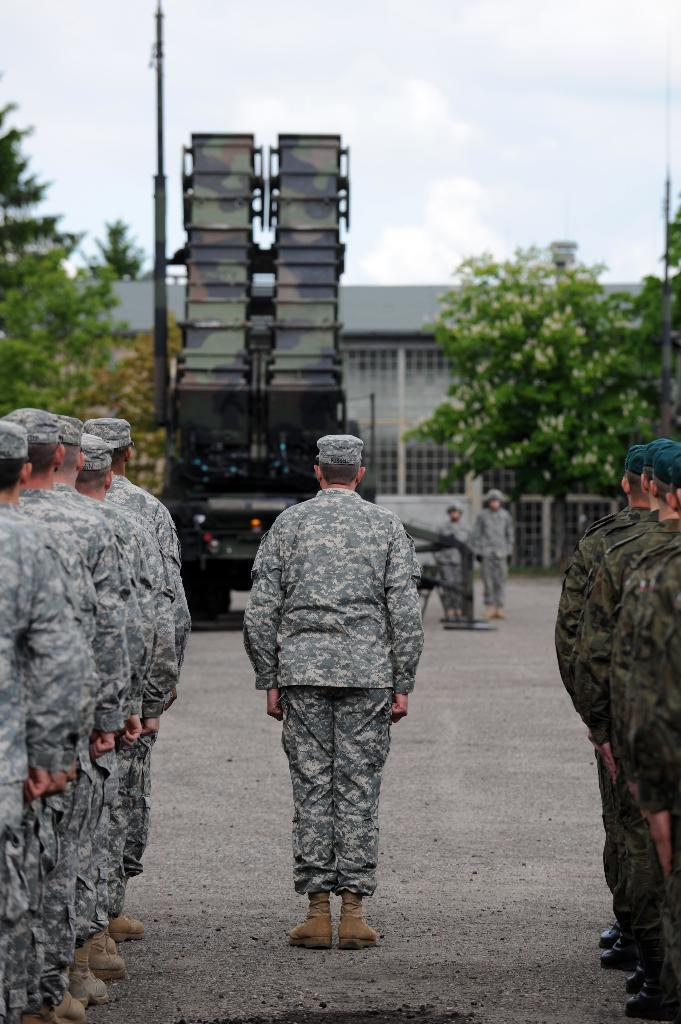What are the people in the image doing? The persons in the image are standing on the road. What type of vehicle can be seen in the image? There is a motor vehicle in the image. What natural elements are present in the image? There are trees in the image. What type of structure is visible in the image? There is a building in the image. What artificial light source is present in the image? There is an electric light in the image. What can be seen in the sky in the image? The sky is visible in the image. What type of celery is being used as a mask by the persons in the image? There is no celery or mask present in the image. What is the topic of the argument taking place between the persons in the image? There is no argument present in the image; the persons are simply standing on the road. 